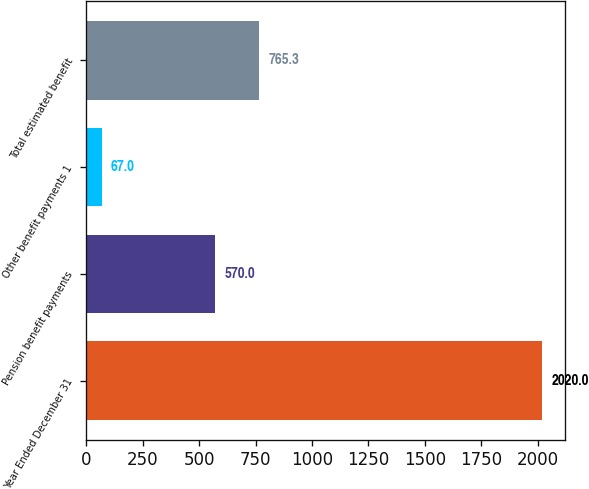Convert chart to OTSL. <chart><loc_0><loc_0><loc_500><loc_500><bar_chart><fcel>Year Ended December 31<fcel>Pension benefit payments<fcel>Other benefit payments 1<fcel>Total estimated benefit<nl><fcel>2020<fcel>570<fcel>67<fcel>765.3<nl></chart> 